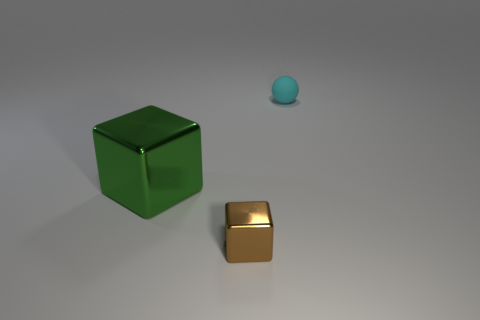There is a brown object that is the same size as the sphere; what material is it?
Give a very brief answer. Metal. There is a metallic thing in front of the large green object; does it have the same size as the thing that is behind the big object?
Keep it short and to the point. Yes. Is there a large purple cylinder made of the same material as the ball?
Offer a very short reply. No. How many things are either metallic objects that are behind the brown thing or gray rubber objects?
Provide a short and direct response. 1. Are the thing that is right of the brown thing and the tiny cube made of the same material?
Offer a very short reply. No. Is the shape of the big object the same as the tiny brown metallic thing?
Offer a very short reply. Yes. What number of matte objects are on the left side of the tiny object that is in front of the cyan matte thing?
Your answer should be compact. 0. There is a green thing that is the same shape as the tiny brown thing; what material is it?
Your response must be concise. Metal. Do the tiny thing that is in front of the small cyan rubber sphere and the big metallic thing have the same color?
Offer a terse response. No. Is the brown cube made of the same material as the tiny thing behind the small metal block?
Your response must be concise. No. 